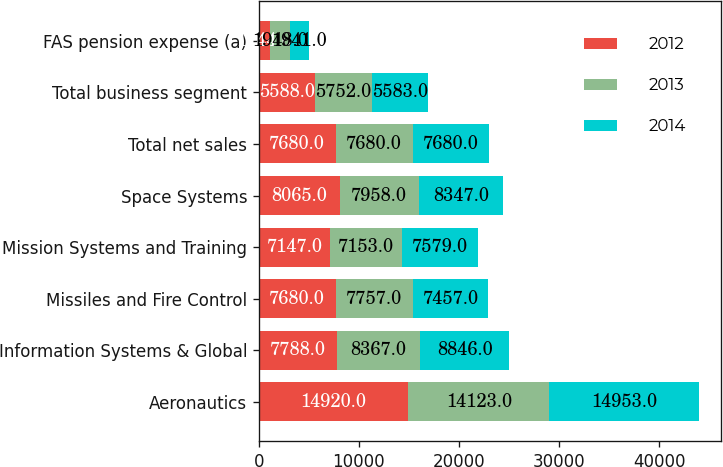Convert chart to OTSL. <chart><loc_0><loc_0><loc_500><loc_500><stacked_bar_chart><ecel><fcel>Aeronautics<fcel>Information Systems & Global<fcel>Missiles and Fire Control<fcel>Mission Systems and Training<fcel>Space Systems<fcel>Total net sales<fcel>Total business segment<fcel>FAS pension expense (a)<nl><fcel>2012<fcel>14920<fcel>7788<fcel>7680<fcel>7147<fcel>8065<fcel>7680<fcel>5588<fcel>1144<nl><fcel>2013<fcel>14123<fcel>8367<fcel>7757<fcel>7153<fcel>7958<fcel>7680<fcel>5752<fcel>1948<nl><fcel>2014<fcel>14953<fcel>8846<fcel>7457<fcel>7579<fcel>8347<fcel>7680<fcel>5583<fcel>1941<nl></chart> 